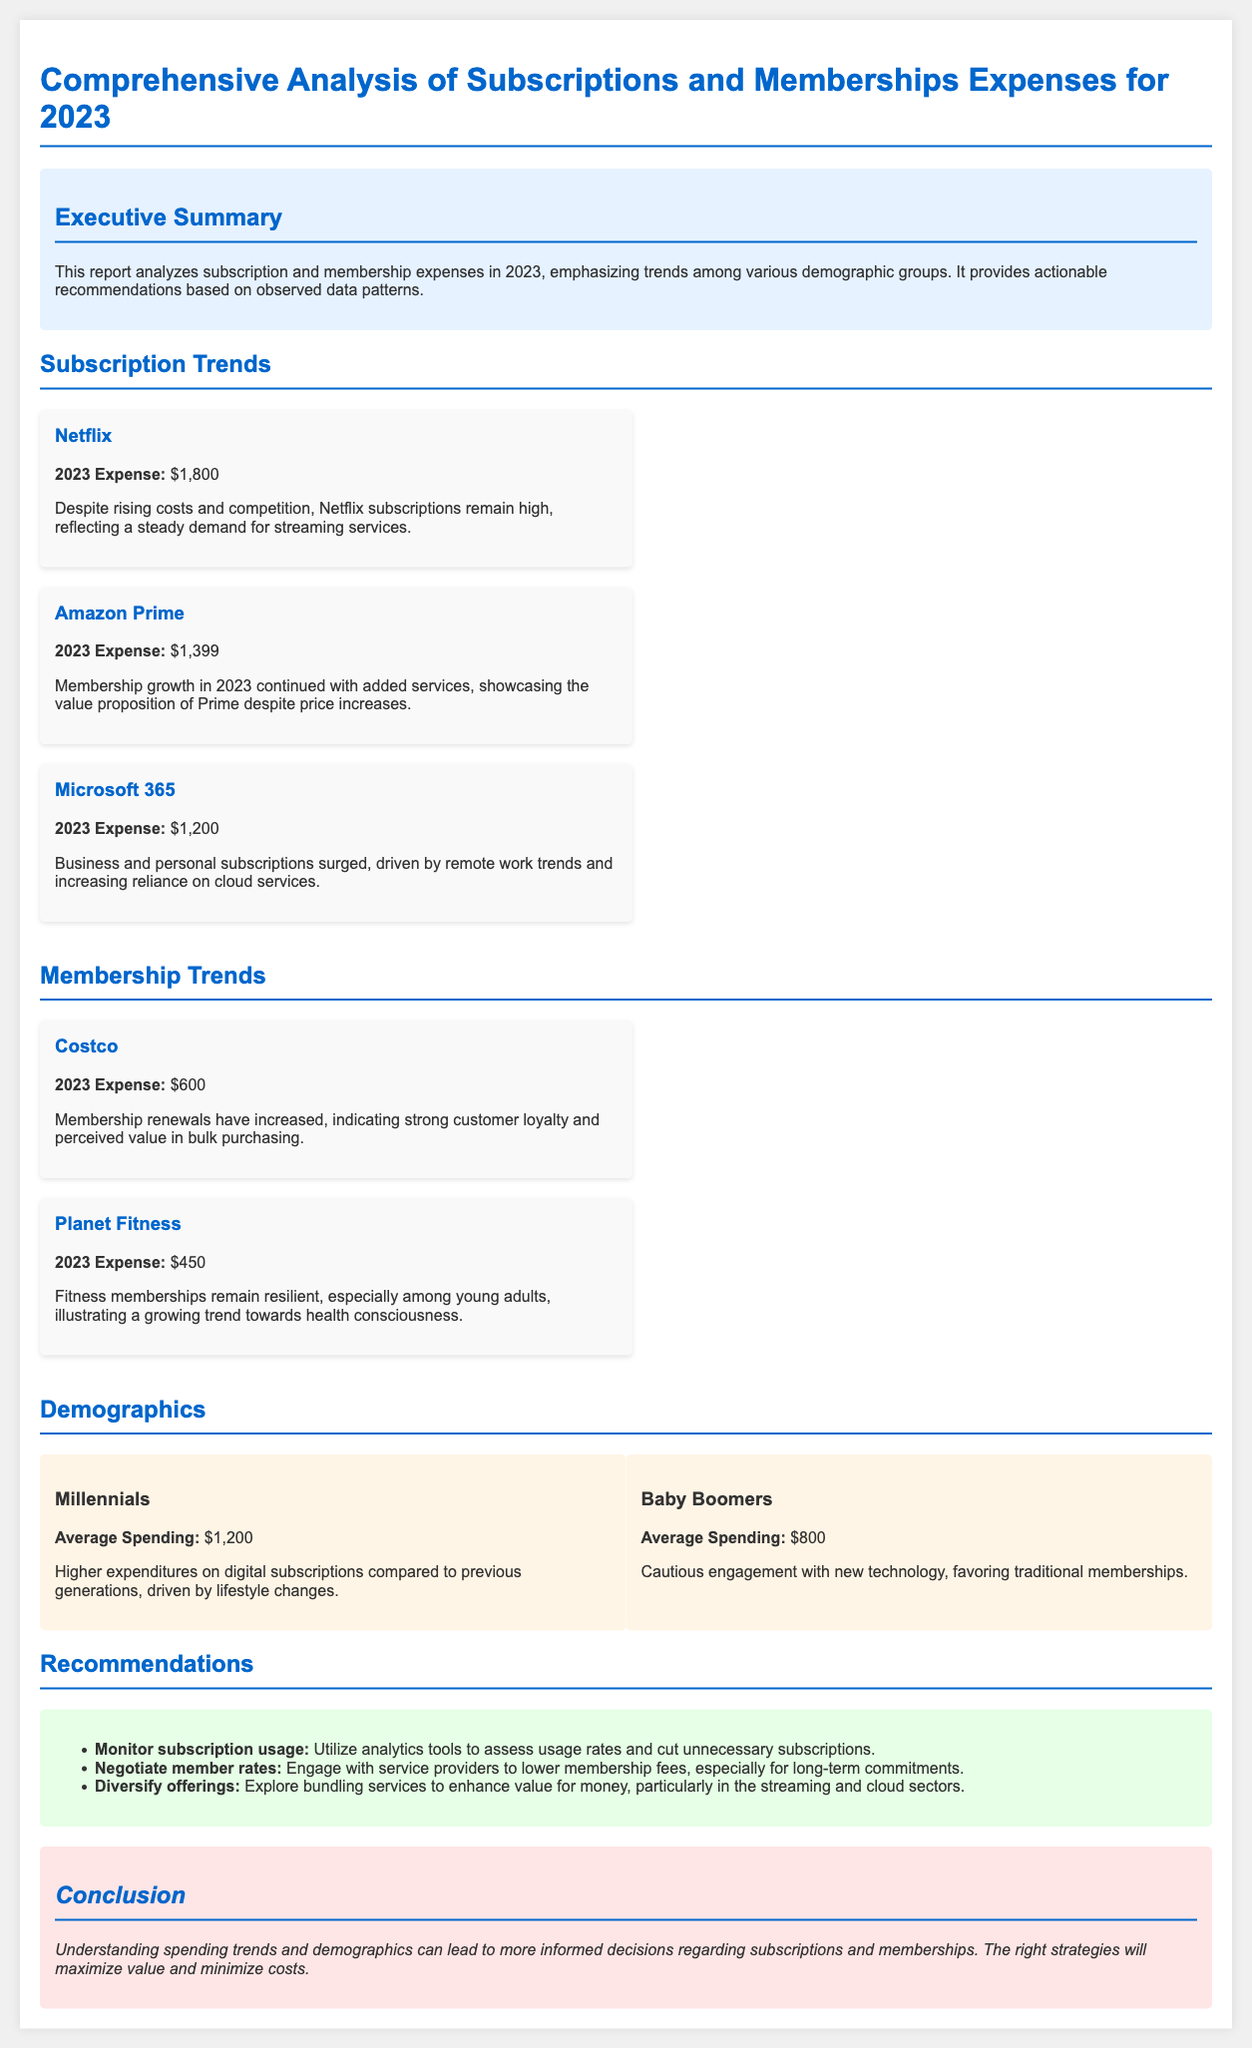What is the total expense for Netflix in 2023? The document states that Netflix's 2023 expense is $1,800.
Answer: $1,800 What demographic group has an average spending of $800? The document specifies that Baby Boomers have an average spending of $800.
Answer: Baby Boomers Which subscription has the highest expense in 2023? Comparing the expenses listed, Netflix has the highest expense at $1,800.
Answer: Netflix How much was spent on Costco memberships in 2023? The document mentions that the expense for Costco memberships in 2023 is $600.
Answer: $600 What is one recommendation provided in the report? The document lists several recommendations, one of which is to monitor subscription usage.
Answer: Monitor subscription usage Which demographic group exhibits higher expenditures on digital subscriptions? The document indicates that Millennials have higher expenditures on digital subscriptions.
Answer: Millennials What was the expense for Amazon Prime in 2023? According to the document, the expense for Amazon Prime in 2023 was $1,399.
Answer: $1,399 What trend is observed in Microsoft 365 subscriptions? The report notes that subscriptions for Microsoft 365 surged due to remote work trends.
Answer: Surged due to remote work trends What color indicates the executive summary section in the report? The executive summary section has a background color of light blue, represented in the document as #e6f2ff.
Answer: Light blue 